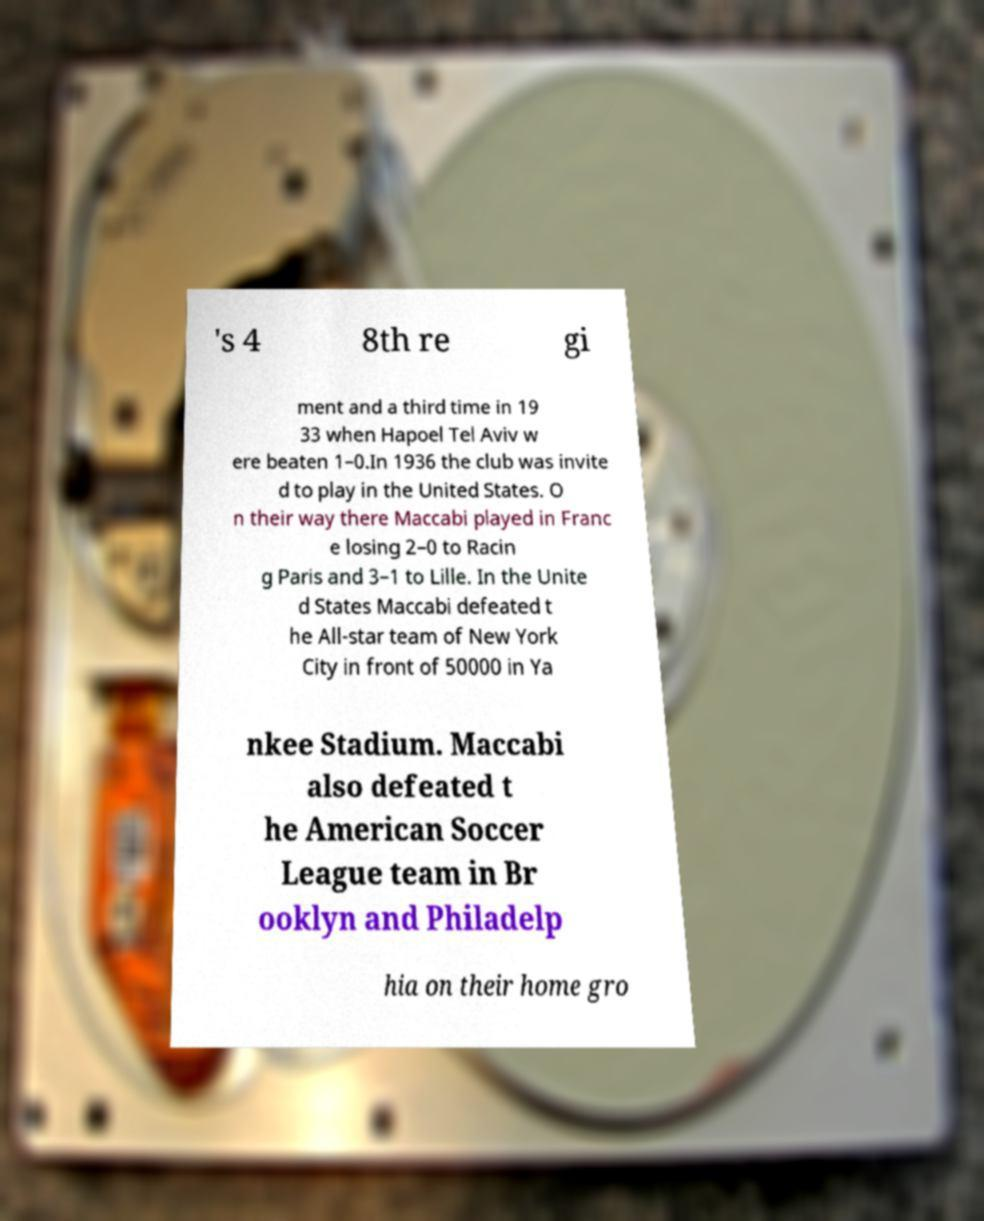Please identify and transcribe the text found in this image. 's 4 8th re gi ment and a third time in 19 33 when Hapoel Tel Aviv w ere beaten 1–0.In 1936 the club was invite d to play in the United States. O n their way there Maccabi played in Franc e losing 2–0 to Racin g Paris and 3–1 to Lille. In the Unite d States Maccabi defeated t he All-star team of New York City in front of 50000 in Ya nkee Stadium. Maccabi also defeated t he American Soccer League team in Br ooklyn and Philadelp hia on their home gro 